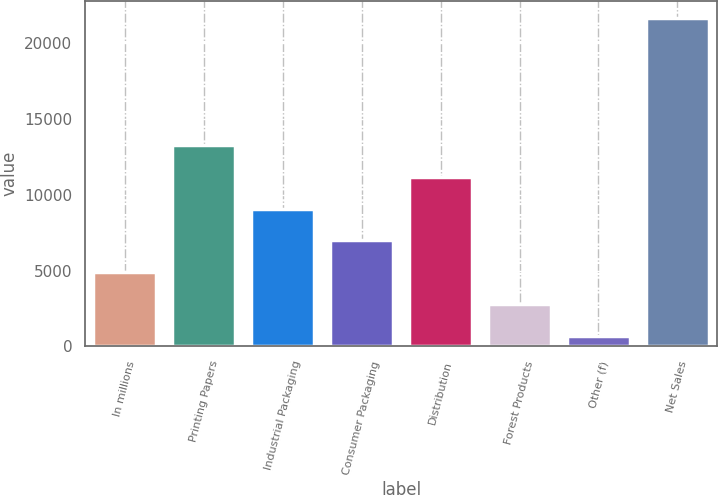Convert chart. <chart><loc_0><loc_0><loc_500><loc_500><bar_chart><fcel>In millions<fcel>Printing Papers<fcel>Industrial Packaging<fcel>Consumer Packaging<fcel>Distribution<fcel>Forest Products<fcel>Other (f)<fcel>Net Sales<nl><fcel>4900.8<fcel>13300.4<fcel>9100.6<fcel>7000.7<fcel>11200.5<fcel>2800.9<fcel>701<fcel>21700<nl></chart> 